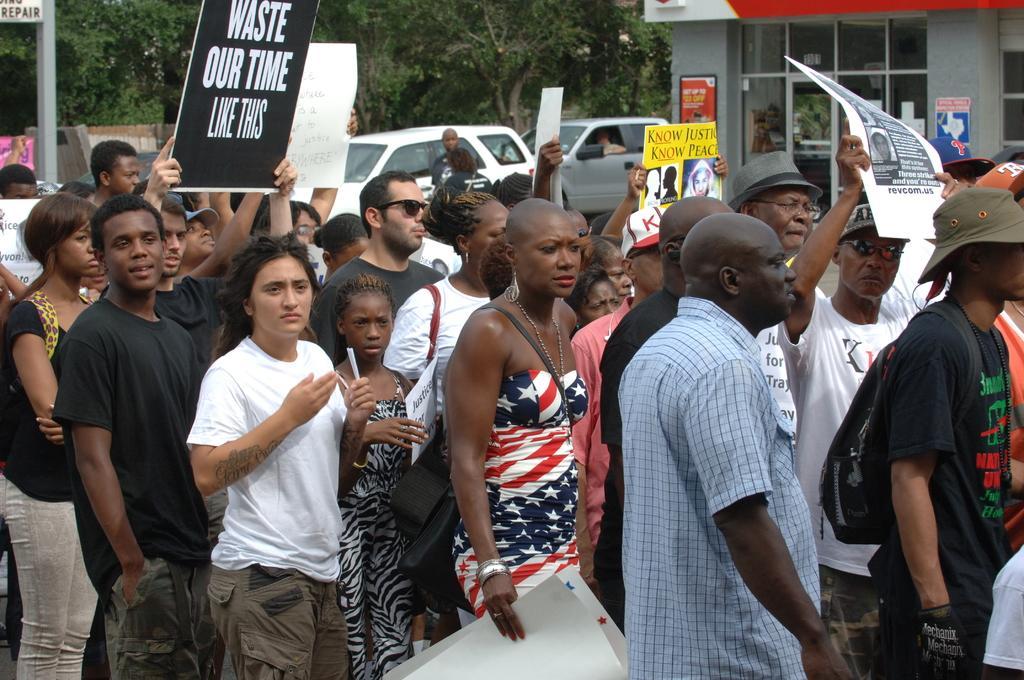Can you describe this image briefly? Here we can see a group of people. Few people are holding posters. Background there are vehicles, building and trees. Here we can see boards. 